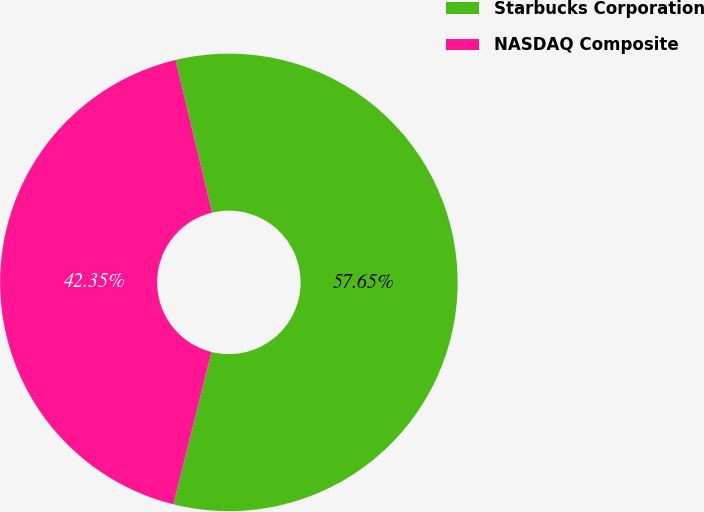Convert chart. <chart><loc_0><loc_0><loc_500><loc_500><pie_chart><fcel>Starbucks Corporation<fcel>NASDAQ Composite<nl><fcel>57.65%<fcel>42.35%<nl></chart> 